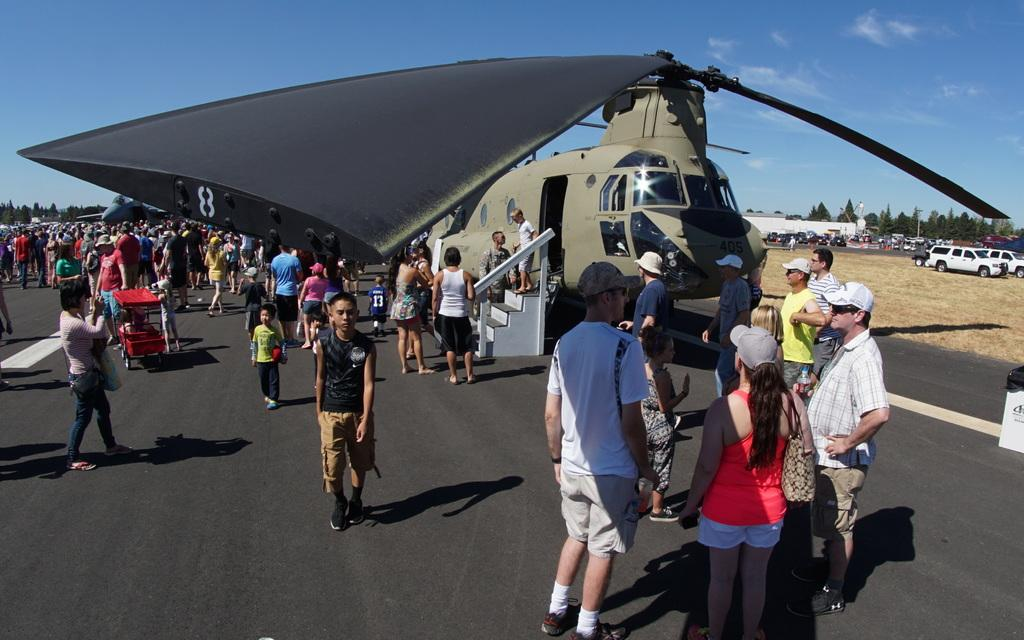What are the people in the image doing? The people in the image are standing on the road. What else can be seen in the sky in the image? A helicopter is visible in the image. What types of vehicles are present on the ground? Vehicles are present on the ground. What can be seen in the background of the image? There are trees, the sky, and other objects in the background of the image. What type of shoes can be seen on the deer in the image? There are no deer or shoes present in the image. What is inside the jar that is visible in the image? There is no jar present in the image. 